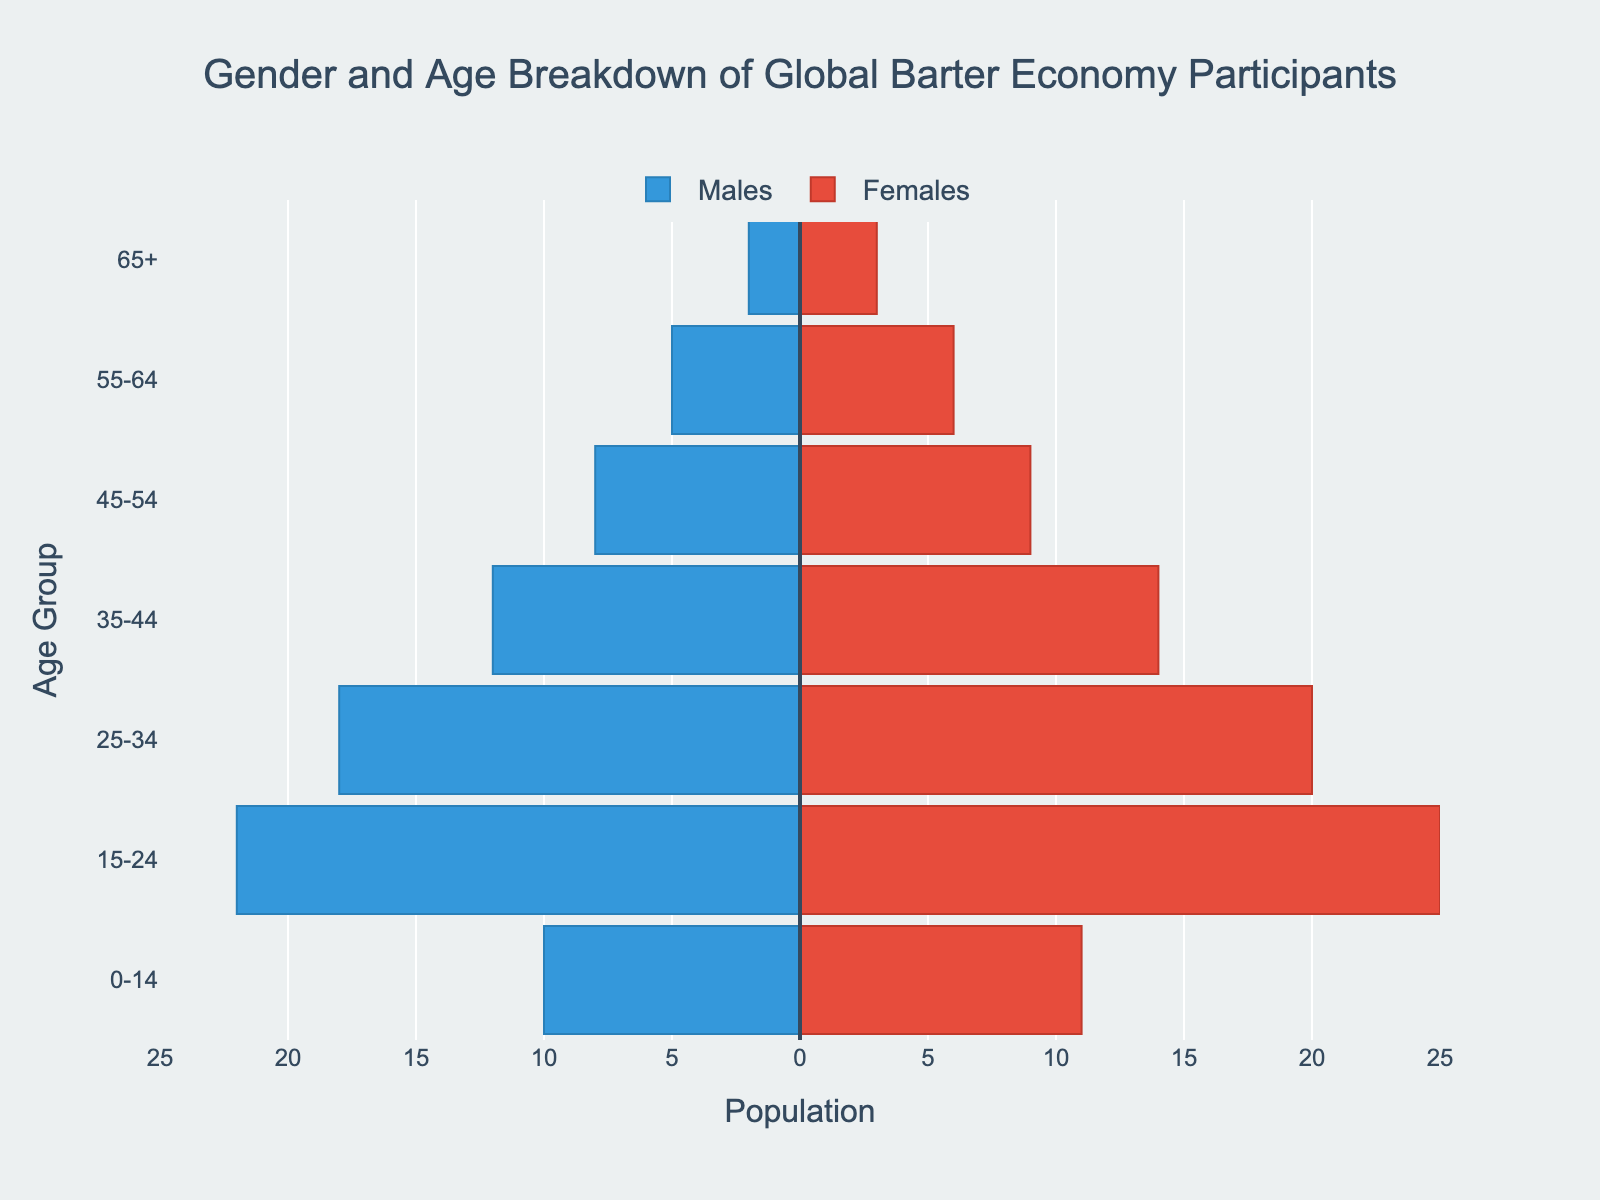What's the title of the figure? The title is displayed prominently above the plot. It helps readers understand the main subject of the figure. The title reads, "Gender and Age Breakdown of Global Barter Economy Participants."
Answer: Gender and Age Breakdown of Global Barter Economy Participants Which age group has the most participants in the barter economy? By observing the lengths of the bars for each age group, the 15-24 age group has the longest bars for both males and females, indicating the highest participation.
Answer: 15-24 How many females are there in the 55-64 age group? Look at the bar corresponding to the 55-64 age group on the right side of the chart, which represents females. The hovertext or the bar length shows the number.
Answer: 6 What's the difference in the number of male and female participants in the 0-14 age group? The 0-14 age group has 10 males and 11 females. Subtract the number of males from the number of females. 11 - 10 = 1
Answer: 1 Which gender has more participants in the 35-44 age group, and by how much? Check the bar lengths for the 35-44 age group. The male bar is 12 and the female bar is 14. Calculate the difference: 14 - 12 = 2. Females have more participants.
Answer: Females, by 2 What is the total number of participants in the 45-54 age group? Add the number of males and females in the 45-54 age group. Males are 8, and females are 9. 8 + 9 = 17
Answer: 17 Compare the population of males aged 25-34 to females aged 55-64. Which is larger, and by how much? The 25-34 male group has 18 participants, while the 55-64 female group has 6. The difference is calculated as 18 - 6 = 12. Males aged 25-34 have more participants.
Answer: Males 25-34, by 12 Across all age groups, which gender has the higher total participation? Summing all male participants: 2 + 5 + 8 + 12 + 18 + 22 + 10 = 77. Summing all female participants: 3 + 6 + 9 + 14 + 20 + 25 + 11 = 88. Females have higher participation.
Answer: Females In the 15-24 age group, what is the ratio of female to male participants? There are 25 females and 22 males in the 15-24 age group. The ratio is calculated as 25:22.
Answer: 25:22 In which age groups do males outnumber females? Observe the comparative lengths of bars for each age group, noting which specific groups have male bars longer than female bars. Only the 0-14 age group fits this criterion.
Answer: 0-14 